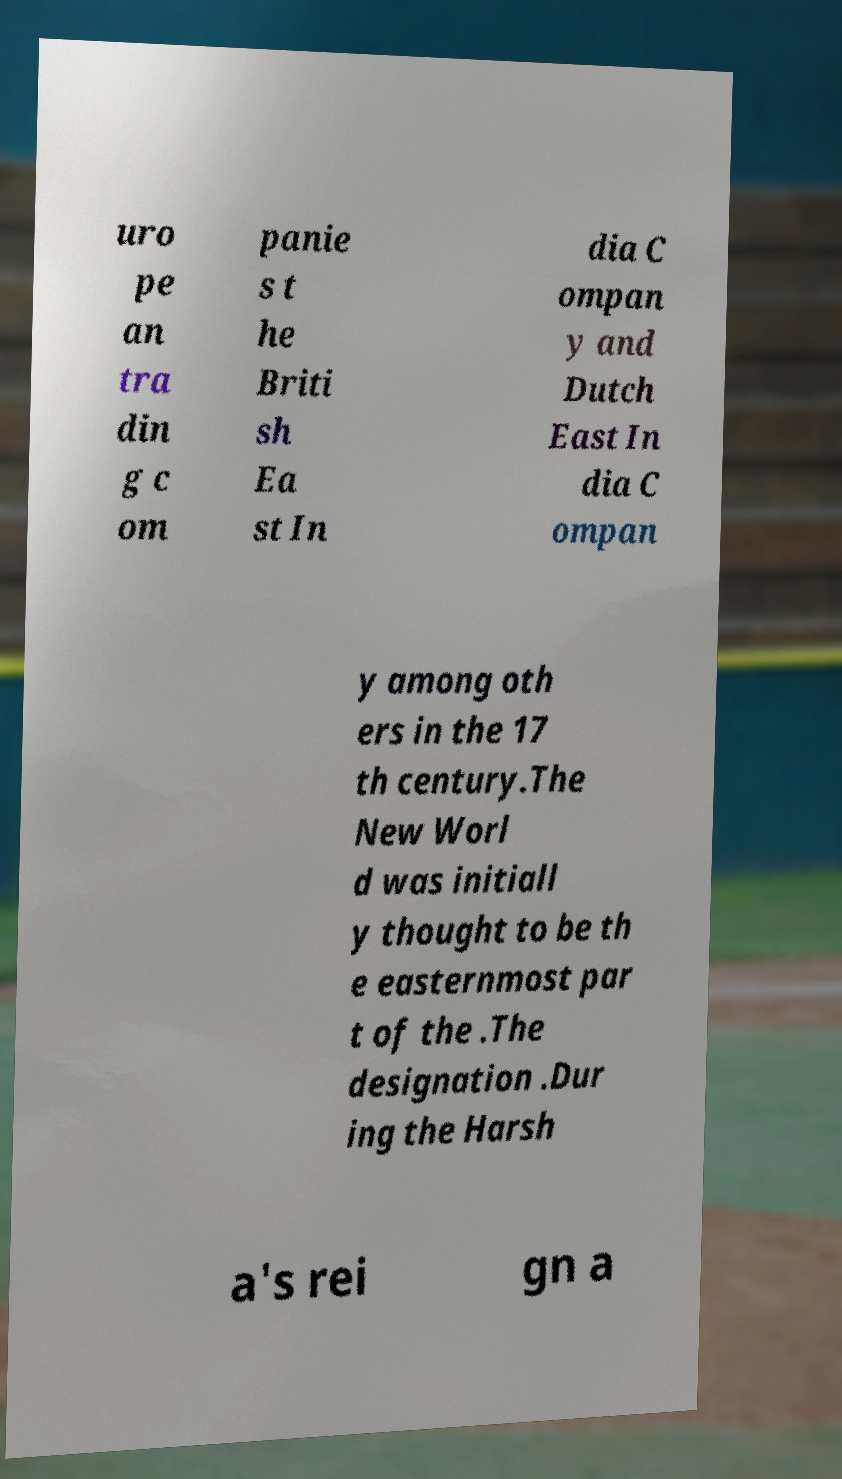There's text embedded in this image that I need extracted. Can you transcribe it verbatim? uro pe an tra din g c om panie s t he Briti sh Ea st In dia C ompan y and Dutch East In dia C ompan y among oth ers in the 17 th century.The New Worl d was initiall y thought to be th e easternmost par t of the .The designation .Dur ing the Harsh a's rei gn a 